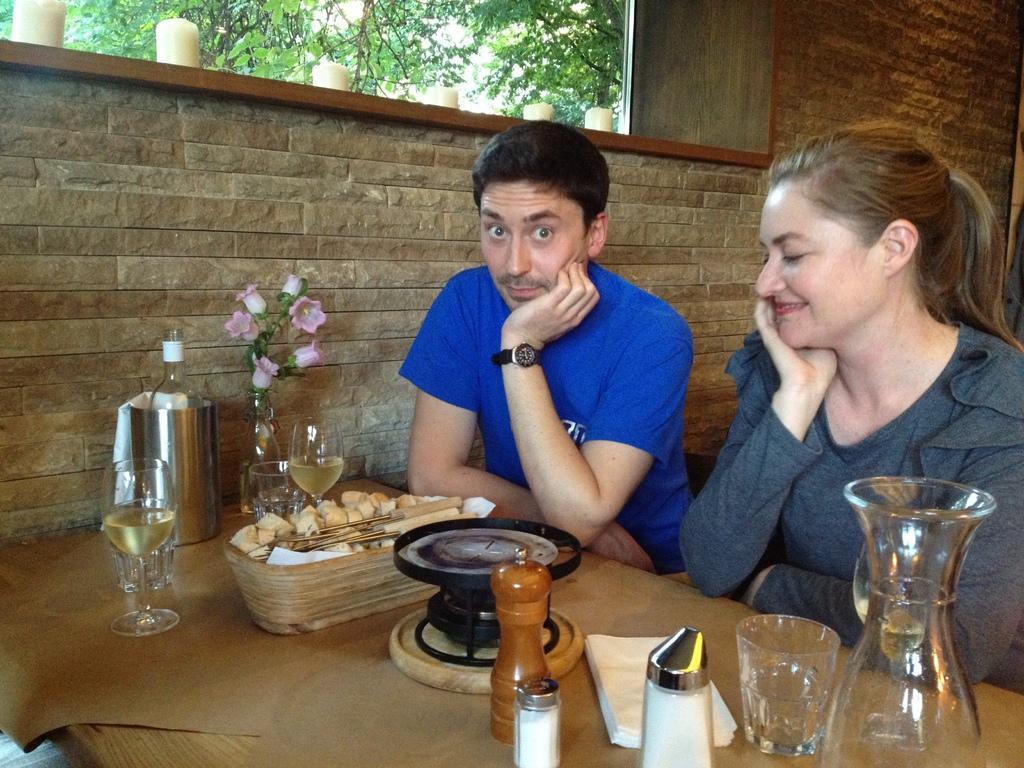How would you summarize this image in a sentence or two? These guys are couple of people sitting on chairs in front of table with a glass of wine in front of them and a flower vase, behind them there are trees. 